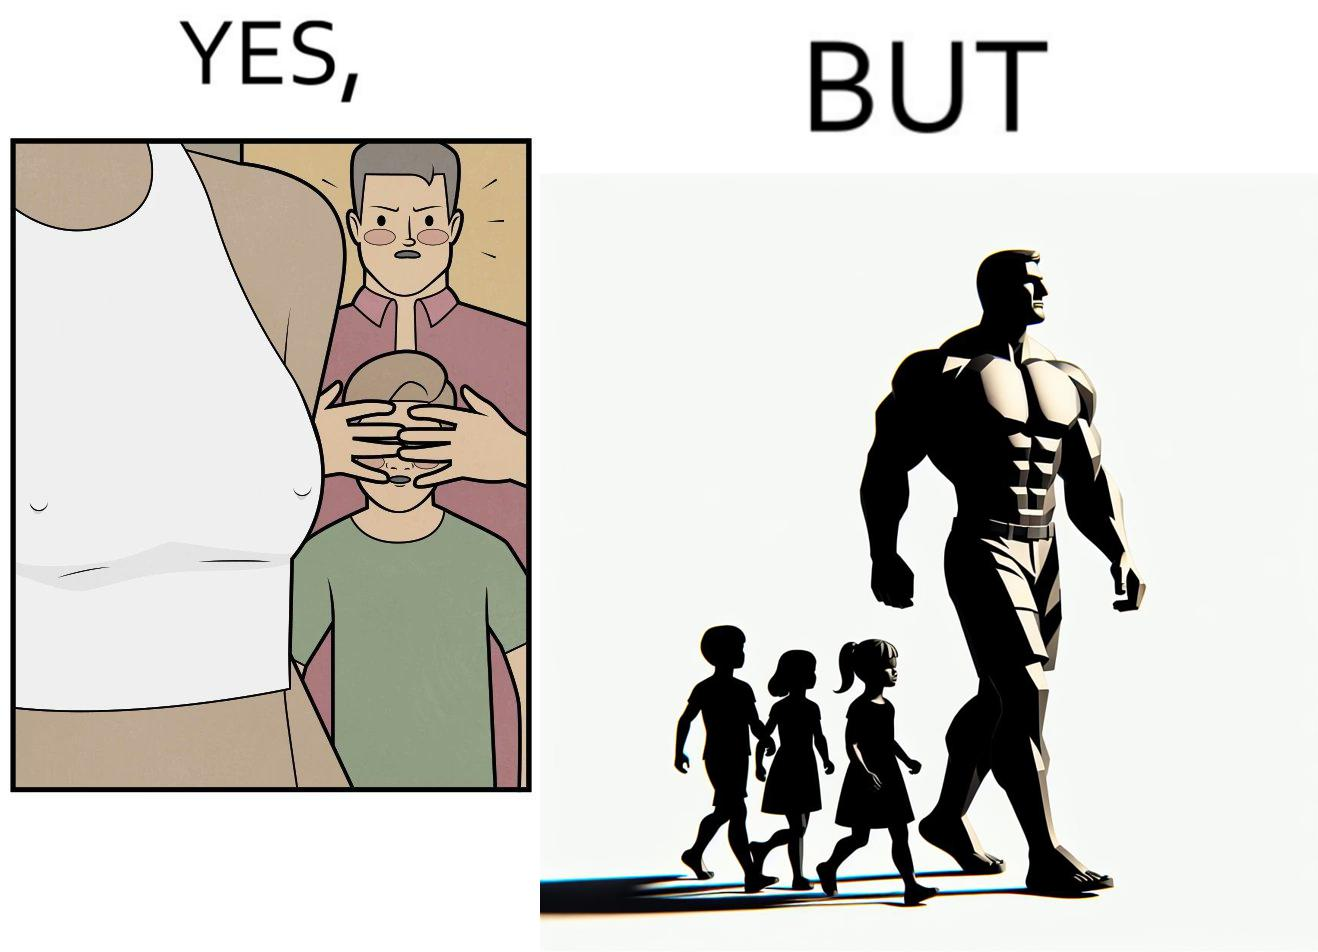Explain the humor or irony in this image. Although the children is hiding his children's eyes from a women but he himself is roaming in shirt open which is showing his body. 